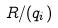Convert formula to latex. <formula><loc_0><loc_0><loc_500><loc_500>R / ( q _ { i } )</formula> 